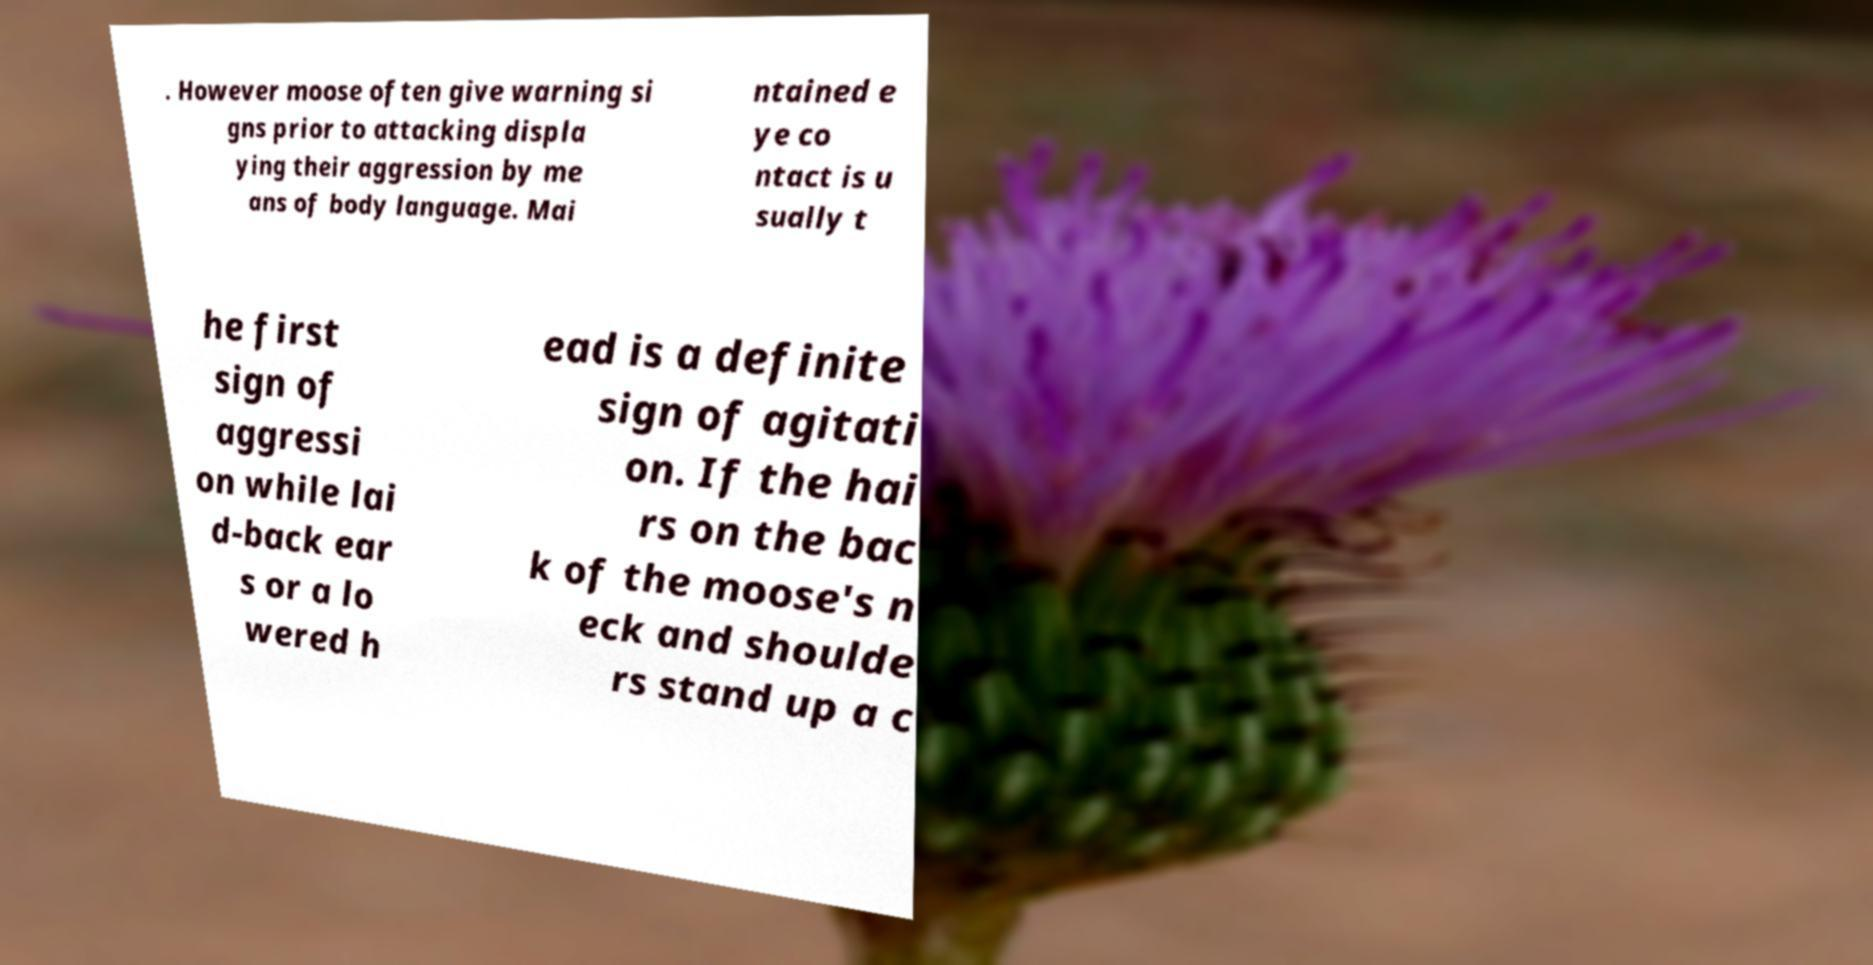Please identify and transcribe the text found in this image. . However moose often give warning si gns prior to attacking displa ying their aggression by me ans of body language. Mai ntained e ye co ntact is u sually t he first sign of aggressi on while lai d-back ear s or a lo wered h ead is a definite sign of agitati on. If the hai rs on the bac k of the moose's n eck and shoulde rs stand up a c 